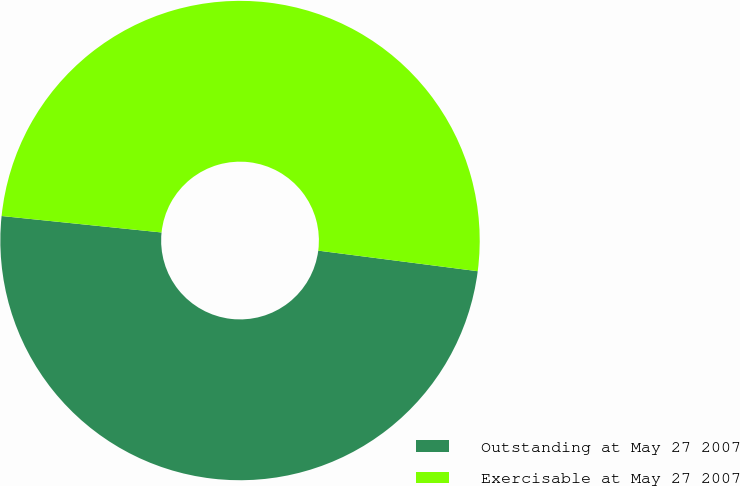<chart> <loc_0><loc_0><loc_500><loc_500><pie_chart><fcel>Outstanding at May 27 2007<fcel>Exercisable at May 27 2007<nl><fcel>49.59%<fcel>50.41%<nl></chart> 